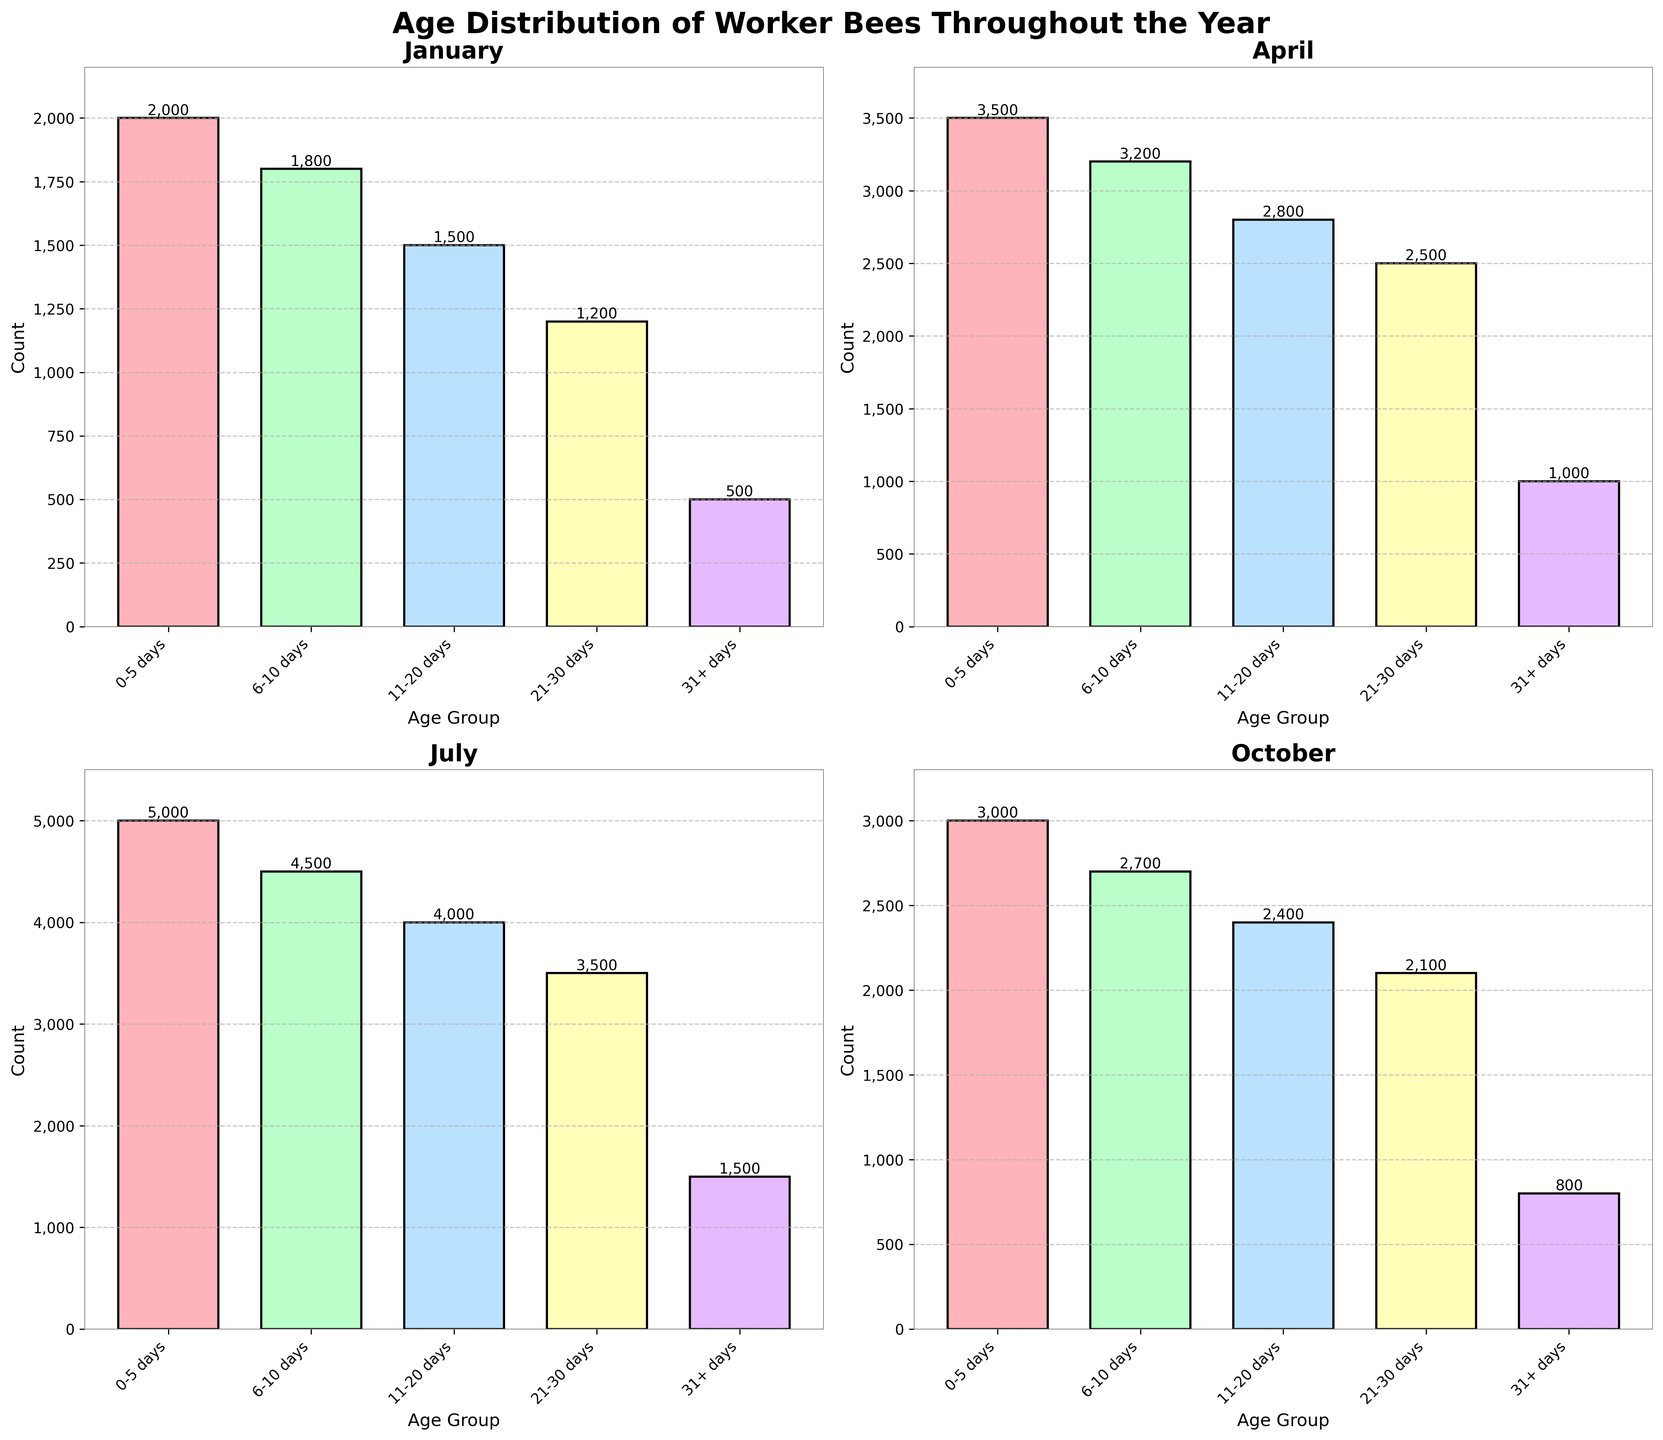Which month had the highest number of worker bees in the age group 0-5 days? Look at the bar heights for the '0-5 days' age group in each subplot. The highest bar corresponds to July.
Answer: July What is the combined number of worker bees aged 31+ days in January and April? Sum the count of worker bees aged 31+ days for January (500) and April (1000).
Answer: 1500 Which age group in July has the smallest number of worker bees? Look at the heights of all the bars in the July subplot and find the smallest one, which corresponds to the age group 31+ days.
Answer: 31+ days How do the counts of worker bees aged 21-30 days in October compare to the same age group in January? Compare the height of the bars for the age group 21-30 days between October (2100) and January (1200). October has more worker bees in that age group.
Answer: October has more In which month is the age distribution of worker bees most balanced? Examine the bar heights across all age groups for each month. April and July show balanced distributions, but April is more evenly spread.
Answer: April What is the difference in the number of worker bees aged 11-20 days between April and October? Subtract the count of worker bees aged 11-20 days in October (2400) from the count in April (2800).
Answer: 400 Which month has the highest total number of worker bees across all age groups? Add the counts for all age groups in each month and compare. July has the highest total.
Answer: July What is the pattern of the number of worker bees aged 0-5 days over the year? By inspecting each subplot, the counts of worker bees aged 0-5 days rise from January (2000) to a peak in July (5000), then decrease in October (3000).
Answer: Rise to peak in July, then decrease in October How does the number of worker bees aged 6-10 days in January compare to the same age group in April and July? Compare the heights of the bars for the age group 6-10 days between January (1800), April (3200), and July (4500). January has fewer worker bees compared to April and July.
Answer: January has fewer 